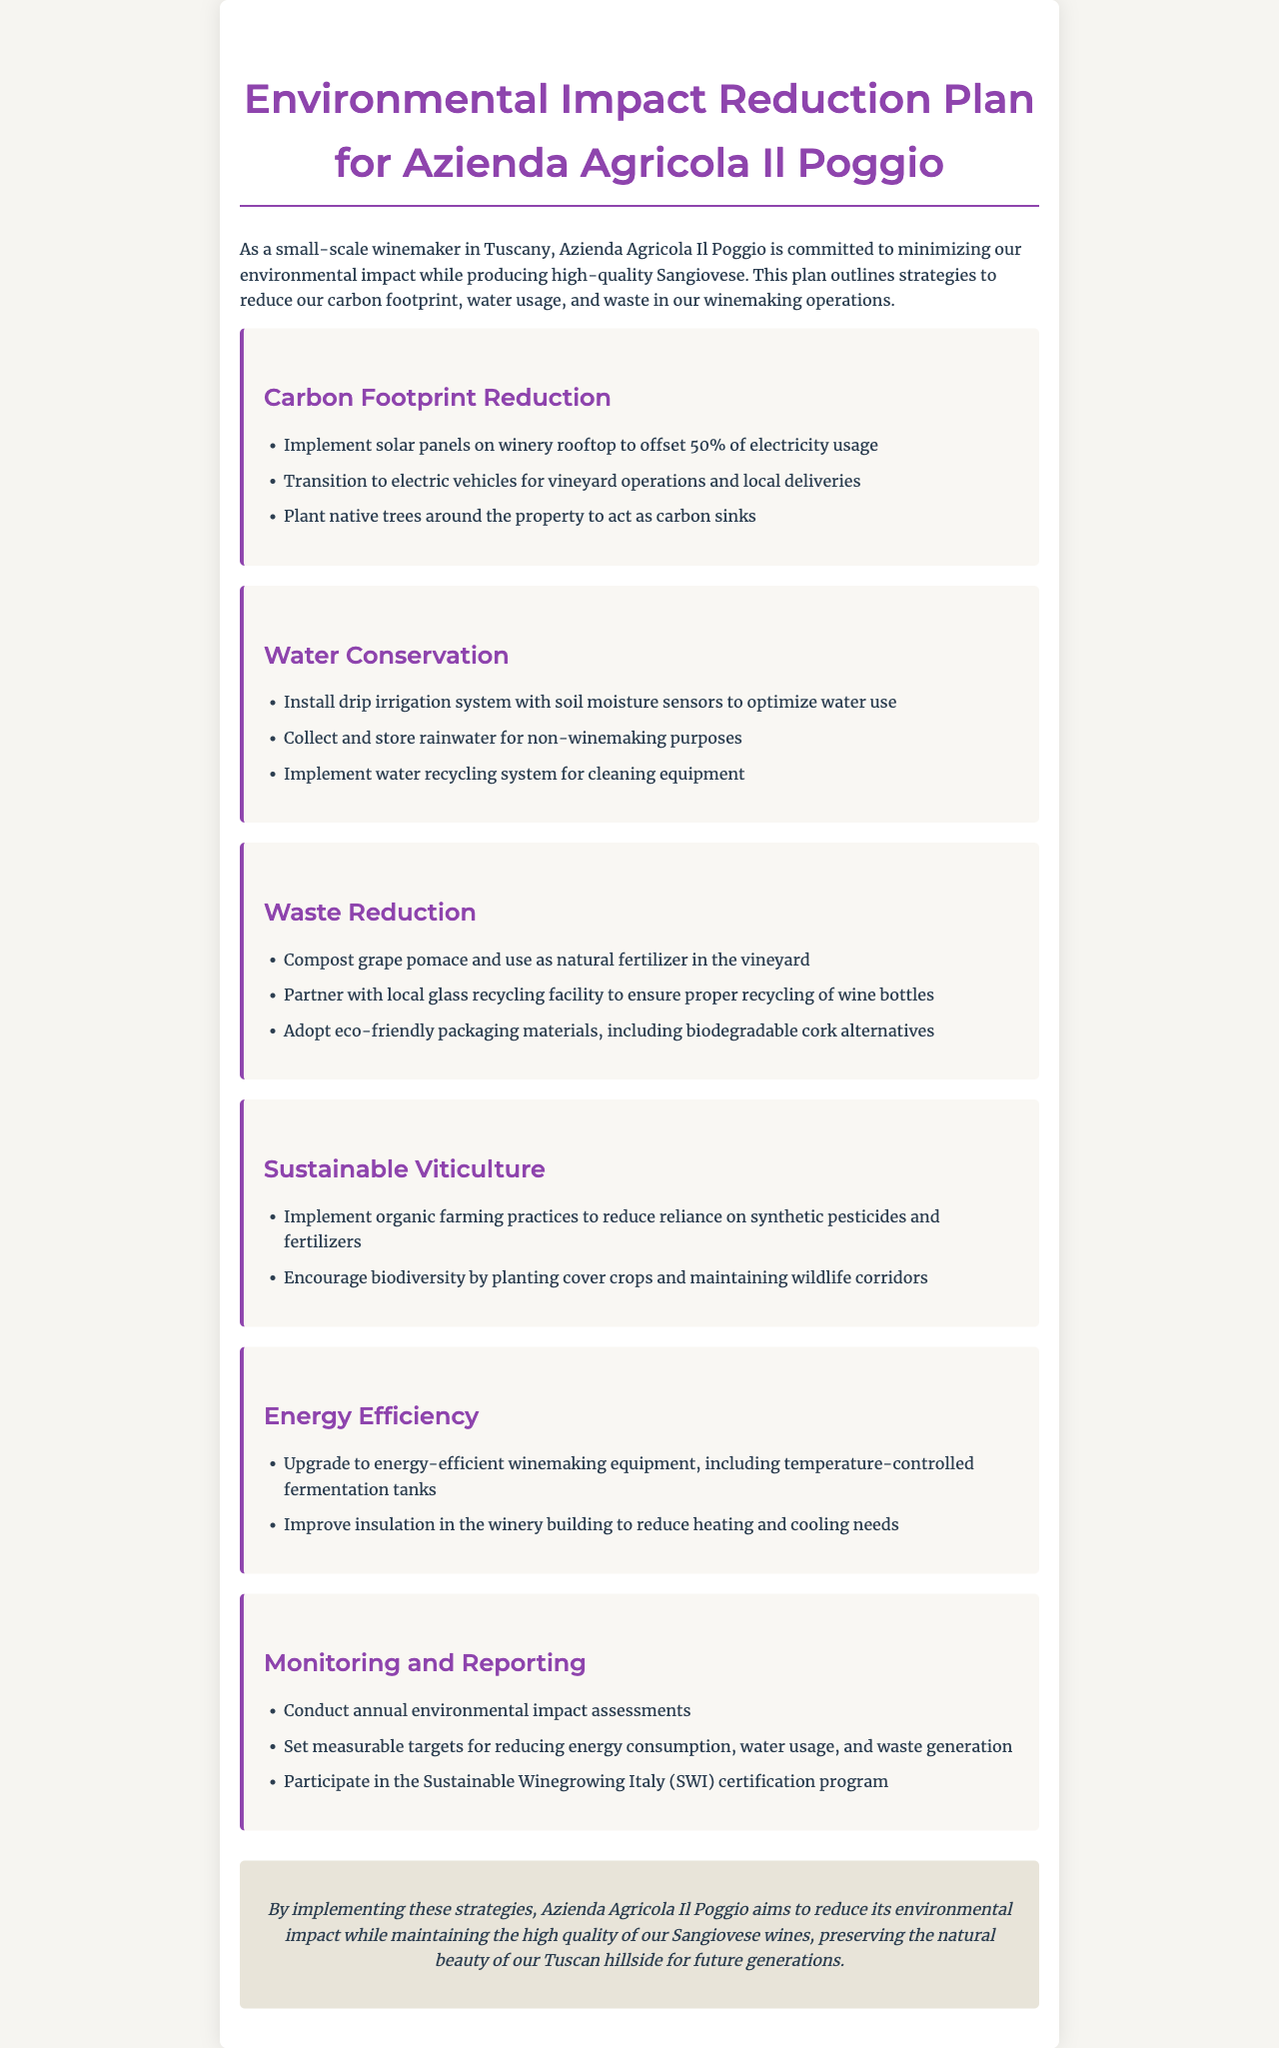What percentage of electricity usage does the solar panel implementation aim to offset? The document states that solar panels are intended to offset 50% of electricity usage.
Answer: 50% What water conservation system is mentioned for optimizing water use? The plan suggests installing a drip irrigation system with soil moisture sensors.
Answer: Drip irrigation system What is one method mentioned for waste reduction in the winery? The document lists composting grape pomace as a waste reduction strategy.
Answer: Compost grape pomace Which certification program does the winery participate in for sustainability? The document mentions participation in the Sustainable Winegrowing Italy (SWI) certification program.
Answer: SWI certification What type of farming practices are encouraged under sustainable viticulture? The document specifies implementing organic farming practices.
Answer: Organic farming practices How often does the winery conduct environmental impact assessments? The document states that assessments are conducted annually.
Answer: Annually What is a proposed energy efficiency upgrade for winemaking equipment? The document includes upgrading to energy-efficient winemaking equipment.
Answer: Energy-efficient winemaking equipment What is the main goal of the Environmental Impact Reduction Plan? The objective is to reduce environmental impact while maintaining wine quality.
Answer: Reduce environmental impact 